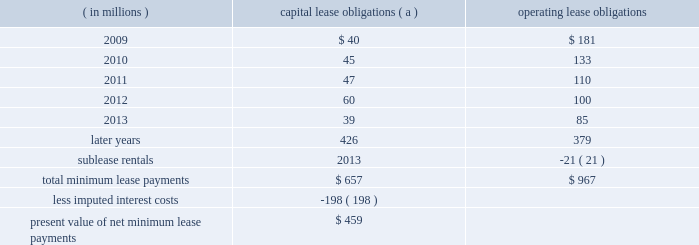Marathon oil corporation notes to consolidated financial statements preferred shares 2013 in connection with the acquisition of western discussed in note 6 , the board of directors authorized a class of voting preferred stock consisting of 6 million shares .
Upon completion of the acquisition , we issued 5 million shares of this voting preferred stock to a trustee , who holds the shares for the benefit of the holders of the exchangeable shares discussed above .
Each share of voting preferred stock is entitled to one vote on all matters submitted to the holders of marathon common stock .
Each holder of exchangeable shares may direct the trustee to vote the number of shares of voting preferred stock equal to the number of shares of marathon common stock issuable upon the exchange of the exchangeable shares held by that holder .
In no event will the aggregate number of votes entitled to be cast by the trustee with respect to the outstanding shares of voting preferred stock exceed the number of votes entitled to be cast with respect to the outstanding exchangeable shares .
Except as otherwise provided in our restated certificate of incorporation or by applicable law , the common stock and the voting preferred stock will vote together as a single class in the election of directors of marathon and on all other matters submitted to a vote of stockholders of marathon generally .
The voting preferred stock will have no other voting rights except as required by law .
Other than dividends payable solely in shares of voting preferred stock , no dividend or other distribution , will be paid or payable to the holder of the voting preferred stock .
In the event of any liquidation , dissolution or winding up of marathon , the holder of shares of the voting preferred stock will not be entitled to receive any assets of marathon available for distribution to its stockholders .
The voting preferred stock is not convertible into any other class or series of the capital stock of marathon or into cash , property or other rights , and may not be redeemed .
26 .
Leases we lease a wide variety of facilities and equipment under operating leases , including land and building space , office equipment , production facilities and transportation equipment .
Most long-term leases include renewal options and , in certain leases , purchase options .
Future minimum commitments for capital lease obligations ( including sale-leasebacks accounted for as financings ) and for operating lease obligations having initial or remaining noncancelable lease terms in excess of one year are as follows : ( in millions ) capital obligations ( a ) operating obligations .
( a ) capital lease obligations includes $ 335 million related to assets under construction as of december 31 , 2008 .
These leases are currently reported in long-term debt based on percentage of construction completed at $ 126 million .
In connection with past sales of various plants and operations , we assigned and the purchasers assumed certain leases of major equipment used in the divested plants and operations of united states steel .
In the event of a default by any of the purchasers , united states steel has assumed these obligations ; however , we remain primarily obligated for payments under these leases .
Minimum lease payments under these operating lease obligations of $ 21 million have been included above and an equal amount has been reported as sublease rentals .
Of the $ 459 million present value of net minimum capital lease payments , $ 69 million was related to obligations assumed by united states steel under the financial matters agreement. .
What are the total undiscounted minimum capital lease obligations in millions without considering the assets under construction as of december 31 , 2008? 
Computations: (657 - 335)
Answer: 322.0. 